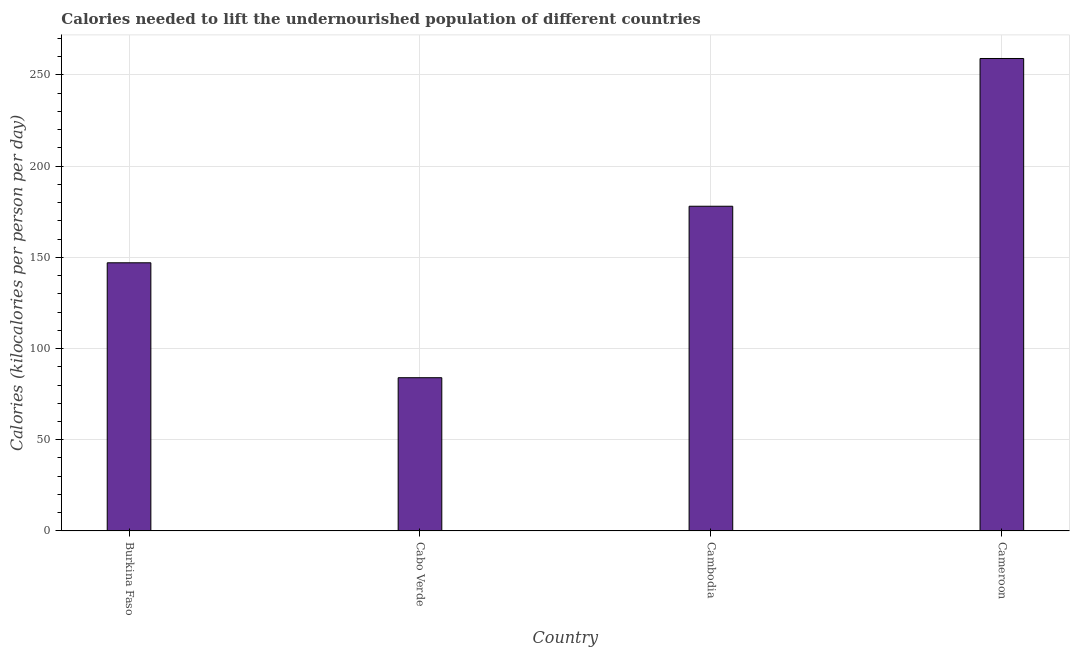Does the graph contain any zero values?
Your response must be concise. No. What is the title of the graph?
Your response must be concise. Calories needed to lift the undernourished population of different countries. What is the label or title of the X-axis?
Give a very brief answer. Country. What is the label or title of the Y-axis?
Ensure brevity in your answer.  Calories (kilocalories per person per day). What is the depth of food deficit in Burkina Faso?
Ensure brevity in your answer.  147. Across all countries, what is the maximum depth of food deficit?
Your answer should be compact. 259. Across all countries, what is the minimum depth of food deficit?
Your response must be concise. 84. In which country was the depth of food deficit maximum?
Offer a terse response. Cameroon. In which country was the depth of food deficit minimum?
Make the answer very short. Cabo Verde. What is the sum of the depth of food deficit?
Give a very brief answer. 668. What is the difference between the depth of food deficit in Burkina Faso and Cambodia?
Give a very brief answer. -31. What is the average depth of food deficit per country?
Give a very brief answer. 167. What is the median depth of food deficit?
Make the answer very short. 162.5. What is the ratio of the depth of food deficit in Burkina Faso to that in Cameroon?
Give a very brief answer. 0.57. Is the depth of food deficit in Cambodia less than that in Cameroon?
Offer a terse response. Yes. Is the difference between the depth of food deficit in Cabo Verde and Cameroon greater than the difference between any two countries?
Your answer should be very brief. Yes. Is the sum of the depth of food deficit in Burkina Faso and Cambodia greater than the maximum depth of food deficit across all countries?
Make the answer very short. Yes. What is the difference between the highest and the lowest depth of food deficit?
Offer a terse response. 175. In how many countries, is the depth of food deficit greater than the average depth of food deficit taken over all countries?
Your answer should be compact. 2. How many countries are there in the graph?
Keep it short and to the point. 4. What is the difference between two consecutive major ticks on the Y-axis?
Provide a short and direct response. 50. Are the values on the major ticks of Y-axis written in scientific E-notation?
Offer a very short reply. No. What is the Calories (kilocalories per person per day) in Burkina Faso?
Your response must be concise. 147. What is the Calories (kilocalories per person per day) of Cambodia?
Provide a short and direct response. 178. What is the Calories (kilocalories per person per day) in Cameroon?
Give a very brief answer. 259. What is the difference between the Calories (kilocalories per person per day) in Burkina Faso and Cambodia?
Ensure brevity in your answer.  -31. What is the difference between the Calories (kilocalories per person per day) in Burkina Faso and Cameroon?
Your answer should be very brief. -112. What is the difference between the Calories (kilocalories per person per day) in Cabo Verde and Cambodia?
Ensure brevity in your answer.  -94. What is the difference between the Calories (kilocalories per person per day) in Cabo Verde and Cameroon?
Your answer should be very brief. -175. What is the difference between the Calories (kilocalories per person per day) in Cambodia and Cameroon?
Your response must be concise. -81. What is the ratio of the Calories (kilocalories per person per day) in Burkina Faso to that in Cabo Verde?
Give a very brief answer. 1.75. What is the ratio of the Calories (kilocalories per person per day) in Burkina Faso to that in Cambodia?
Offer a very short reply. 0.83. What is the ratio of the Calories (kilocalories per person per day) in Burkina Faso to that in Cameroon?
Ensure brevity in your answer.  0.57. What is the ratio of the Calories (kilocalories per person per day) in Cabo Verde to that in Cambodia?
Your answer should be compact. 0.47. What is the ratio of the Calories (kilocalories per person per day) in Cabo Verde to that in Cameroon?
Make the answer very short. 0.32. What is the ratio of the Calories (kilocalories per person per day) in Cambodia to that in Cameroon?
Keep it short and to the point. 0.69. 